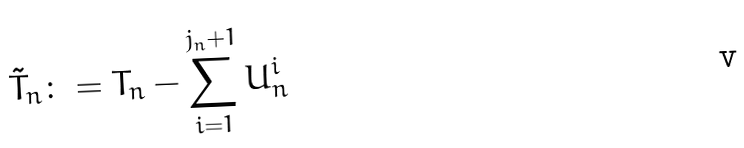Convert formula to latex. <formula><loc_0><loc_0><loc_500><loc_500>\tilde { T } _ { n } \colon = T _ { n } - \sum _ { i = 1 } ^ { j _ { n } + 1 } U _ { n } ^ { i }</formula> 